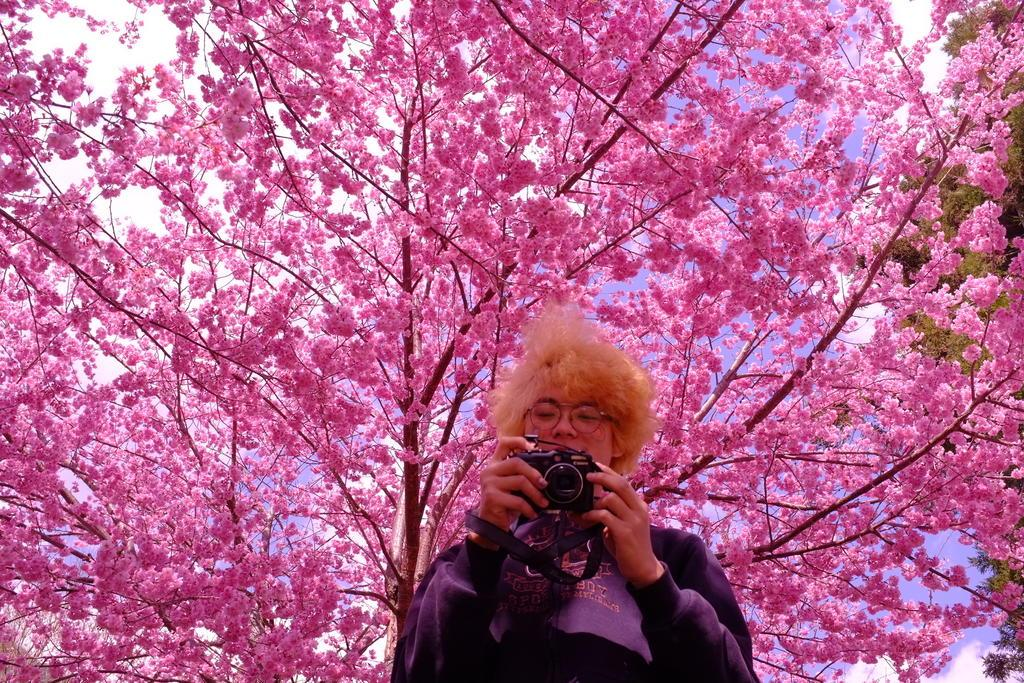What is the person in the image doing? The person is standing in the image and holding a camera. What can be seen behind the person? There is a pink tree behind the person. What other tree is visible in the image? There is a green tree in the right corner of the image. What type of jelly is the person eating in the image? There is no jelly present in the image; the person is holding a camera. Can you tell me how many fathers are in the image? There is no mention of a father or any group of people in the image; it only features a person holding a camera. 